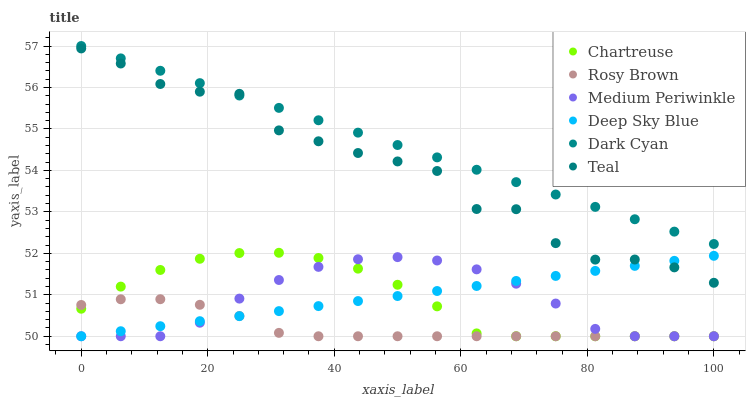Does Rosy Brown have the minimum area under the curve?
Answer yes or no. Yes. Does Dark Cyan have the maximum area under the curve?
Answer yes or no. Yes. Does Medium Periwinkle have the minimum area under the curve?
Answer yes or no. No. Does Medium Periwinkle have the maximum area under the curve?
Answer yes or no. No. Is Deep Sky Blue the smoothest?
Answer yes or no. Yes. Is Teal the roughest?
Answer yes or no. Yes. Is Rosy Brown the smoothest?
Answer yes or no. No. Is Rosy Brown the roughest?
Answer yes or no. No. Does Deep Sky Blue have the lowest value?
Answer yes or no. Yes. Does Teal have the lowest value?
Answer yes or no. No. Does Dark Cyan have the highest value?
Answer yes or no. Yes. Does Medium Periwinkle have the highest value?
Answer yes or no. No. Is Medium Periwinkle less than Dark Cyan?
Answer yes or no. Yes. Is Dark Cyan greater than Chartreuse?
Answer yes or no. Yes. Does Deep Sky Blue intersect Rosy Brown?
Answer yes or no. Yes. Is Deep Sky Blue less than Rosy Brown?
Answer yes or no. No. Is Deep Sky Blue greater than Rosy Brown?
Answer yes or no. No. Does Medium Periwinkle intersect Dark Cyan?
Answer yes or no. No. 